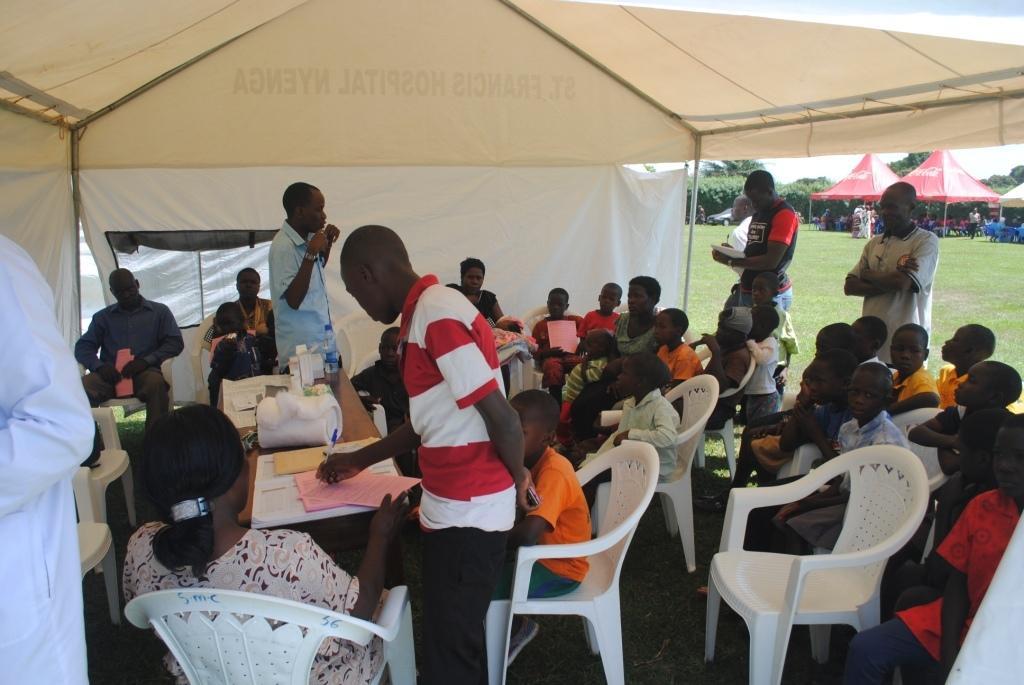Could you give a brief overview of what you see in this image? In this picture we can see a group of people some are sitting on chairs and some are standing here in middle we can see table and on table we have bottle, papers and this people are inside the tent and in background we can see some tents, persons, trees. 